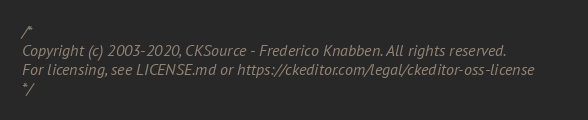<code> <loc_0><loc_0><loc_500><loc_500><_CSS_>/*
Copyright (c) 2003-2020, CKSource - Frederico Knabben. All rights reserved.
For licensing, see LICENSE.md or https://ckeditor.com/legal/ckeditor-oss-license
*/</code> 